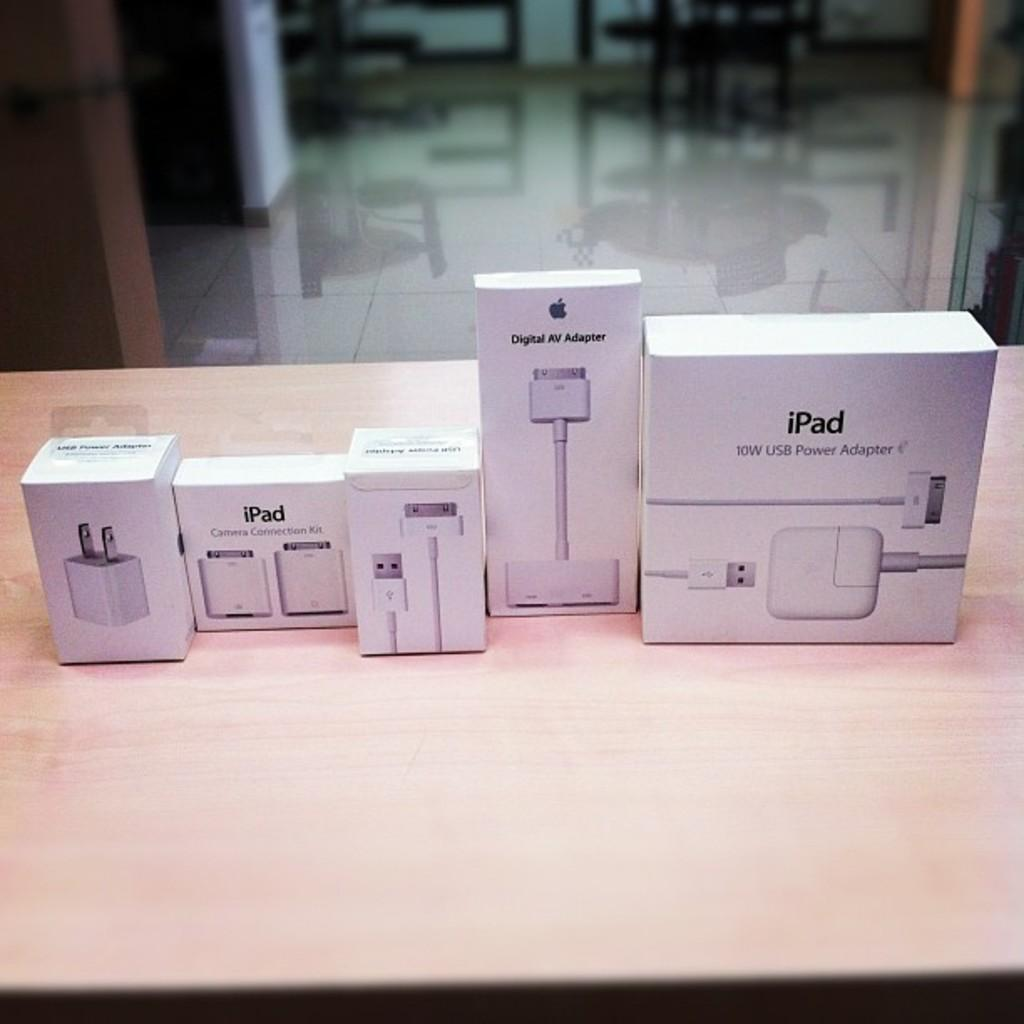<image>
Summarize the visual content of the image. some boxes of iPad accessories for your iPad itself. 